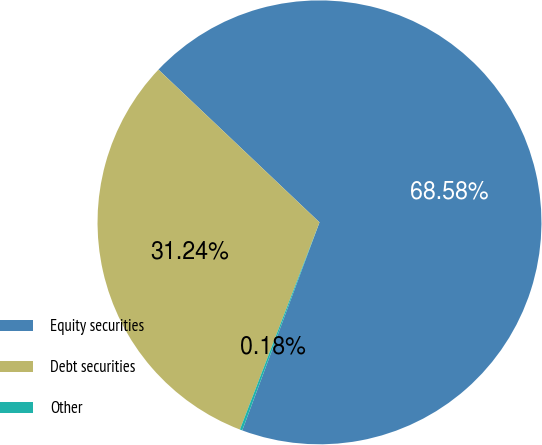<chart> <loc_0><loc_0><loc_500><loc_500><pie_chart><fcel>Equity securities<fcel>Debt securities<fcel>Other<nl><fcel>68.57%<fcel>31.24%<fcel>0.18%<nl></chart> 